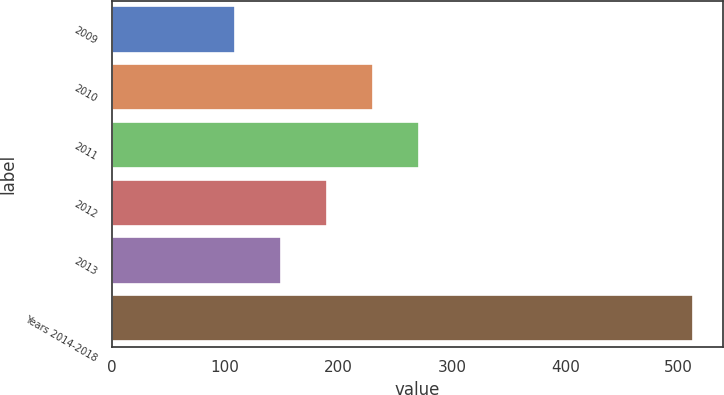Convert chart. <chart><loc_0><loc_0><loc_500><loc_500><bar_chart><fcel>2009<fcel>2010<fcel>2011<fcel>2012<fcel>2013<fcel>Years 2014-2018<nl><fcel>109<fcel>230.2<fcel>270.6<fcel>189.8<fcel>149.4<fcel>513<nl></chart> 